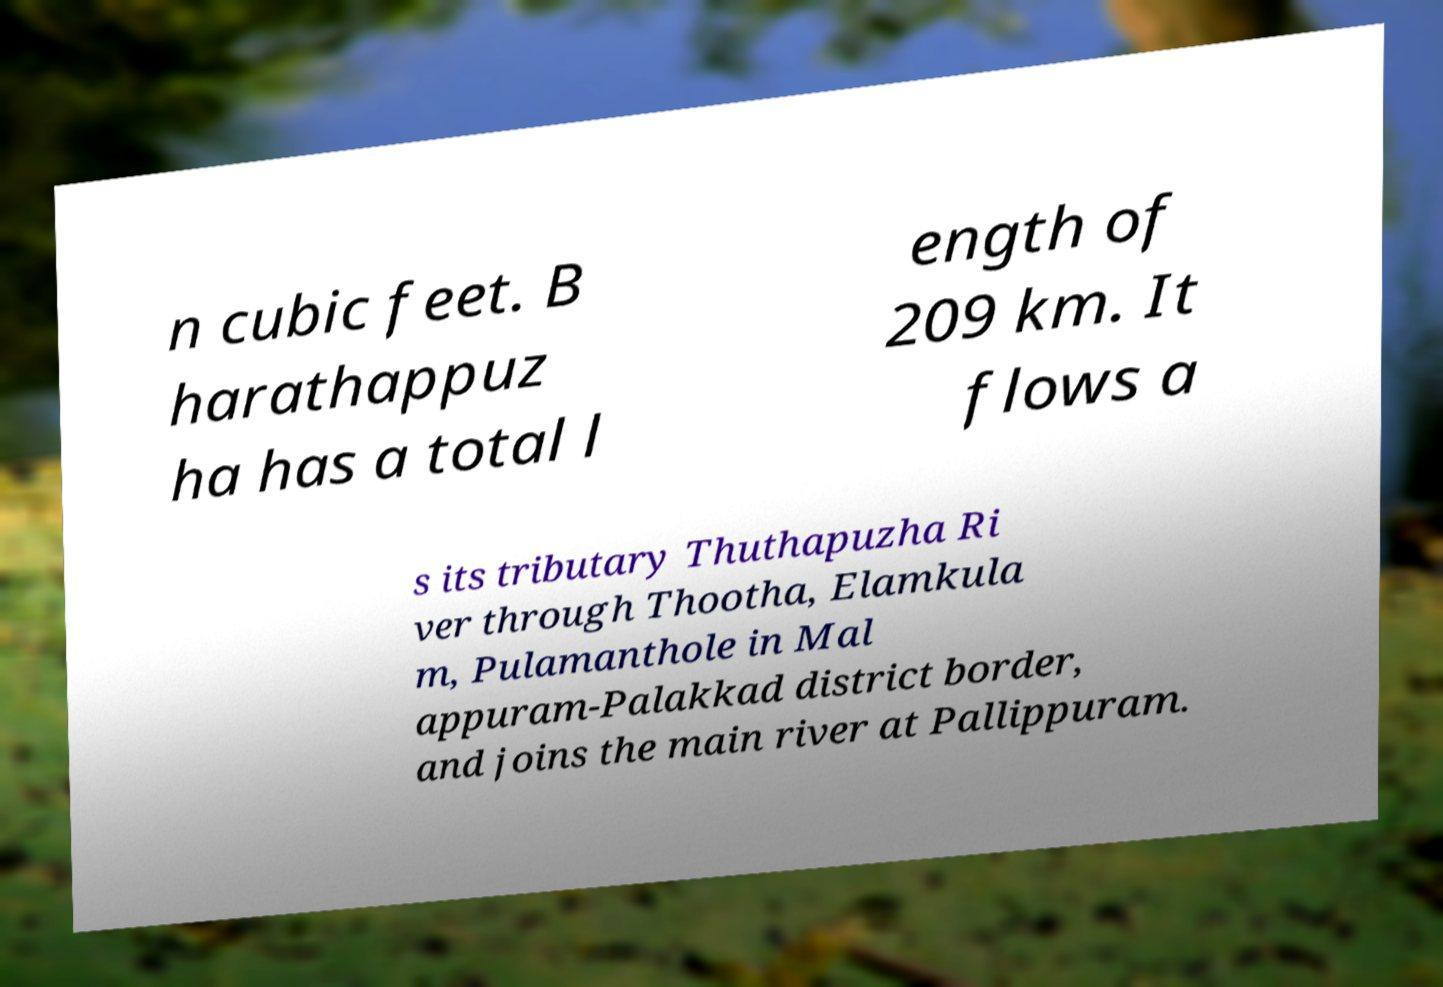What messages or text are displayed in this image? I need them in a readable, typed format. n cubic feet. B harathappuz ha has a total l ength of 209 km. It flows a s its tributary Thuthapuzha Ri ver through Thootha, Elamkula m, Pulamanthole in Mal appuram-Palakkad district border, and joins the main river at Pallippuram. 